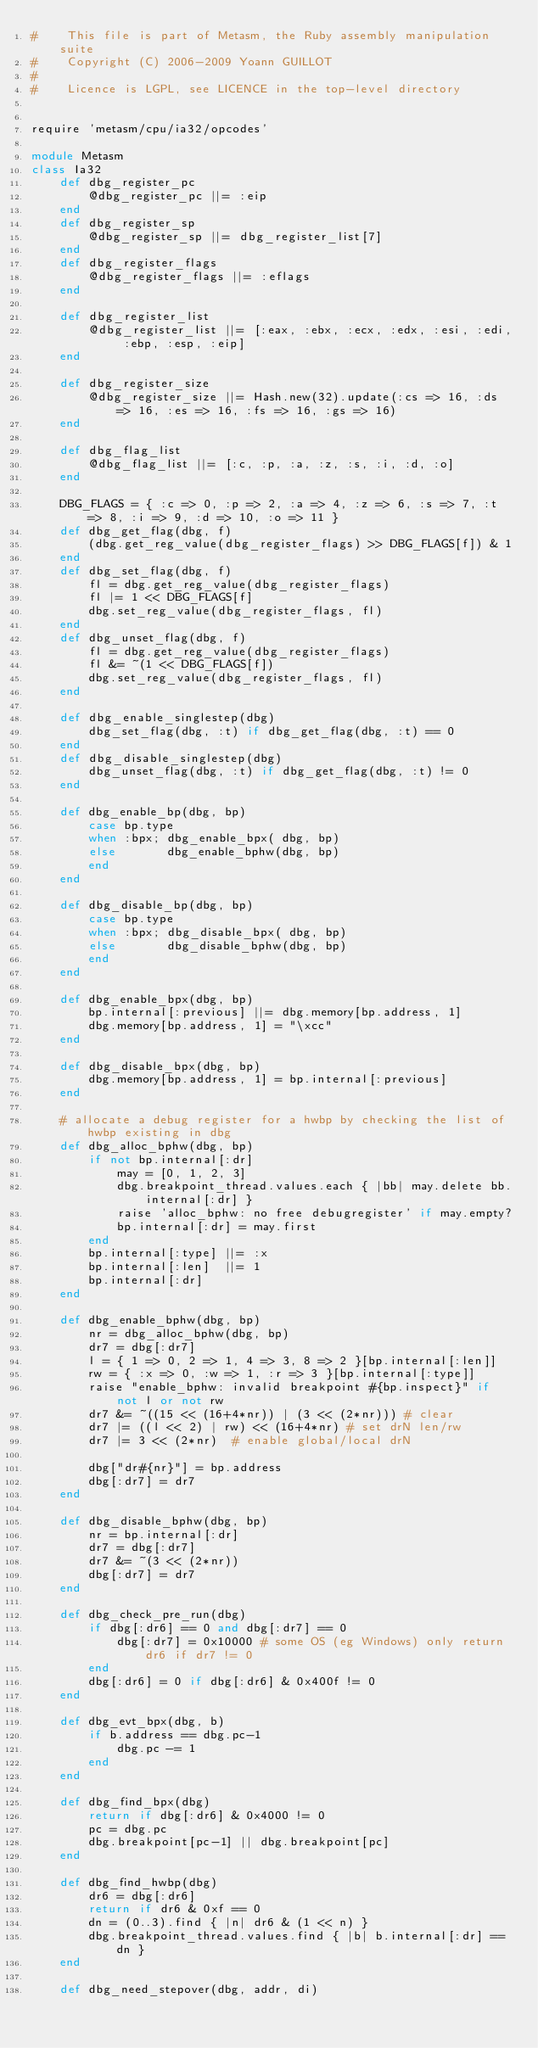<code> <loc_0><loc_0><loc_500><loc_500><_Ruby_>#    This file is part of Metasm, the Ruby assembly manipulation suite
#    Copyright (C) 2006-2009 Yoann GUILLOT
#
#    Licence is LGPL, see LICENCE in the top-level directory


require 'metasm/cpu/ia32/opcodes'

module Metasm
class Ia32
	def dbg_register_pc
		@dbg_register_pc ||= :eip
	end
	def dbg_register_sp
		@dbg_register_sp ||= dbg_register_list[7]
	end
	def dbg_register_flags
		@dbg_register_flags ||= :eflags
	end

	def dbg_register_list
		@dbg_register_list ||= [:eax, :ebx, :ecx, :edx, :esi, :edi, :ebp, :esp, :eip]
	end

	def dbg_register_size
		@dbg_register_size ||= Hash.new(32).update(:cs => 16, :ds => 16, :es => 16, :fs => 16, :gs => 16)
	end

	def dbg_flag_list
		@dbg_flag_list ||= [:c, :p, :a, :z, :s, :i, :d, :o]
	end

	DBG_FLAGS = { :c => 0, :p => 2, :a => 4, :z => 6, :s => 7, :t => 8, :i => 9, :d => 10, :o => 11 }
	def dbg_get_flag(dbg, f)
		(dbg.get_reg_value(dbg_register_flags) >> DBG_FLAGS[f]) & 1
	end
	def dbg_set_flag(dbg, f)
		fl = dbg.get_reg_value(dbg_register_flags)
		fl |= 1 << DBG_FLAGS[f]
		dbg.set_reg_value(dbg_register_flags, fl)
	end
	def dbg_unset_flag(dbg, f)
		fl = dbg.get_reg_value(dbg_register_flags)
		fl &= ~(1 << DBG_FLAGS[f])
		dbg.set_reg_value(dbg_register_flags, fl)
	end

	def dbg_enable_singlestep(dbg)
		dbg_set_flag(dbg, :t) if dbg_get_flag(dbg, :t) == 0
	end
	def dbg_disable_singlestep(dbg)
		dbg_unset_flag(dbg, :t) if dbg_get_flag(dbg, :t) != 0
	end

	def dbg_enable_bp(dbg, bp)
		case bp.type
		when :bpx; dbg_enable_bpx( dbg, bp)
		else       dbg_enable_bphw(dbg, bp)
		end
	end

	def dbg_disable_bp(dbg, bp)
		case bp.type
		when :bpx; dbg_disable_bpx( dbg, bp)
		else       dbg_disable_bphw(dbg, bp)
		end
	end

	def dbg_enable_bpx(dbg, bp)
		bp.internal[:previous] ||= dbg.memory[bp.address, 1]
		dbg.memory[bp.address, 1] = "\xcc"
	end

	def dbg_disable_bpx(dbg, bp)
		dbg.memory[bp.address, 1] = bp.internal[:previous]
	end

	# allocate a debug register for a hwbp by checking the list of hwbp existing in dbg
	def dbg_alloc_bphw(dbg, bp)
		if not bp.internal[:dr]
			may = [0, 1, 2, 3]
			dbg.breakpoint_thread.values.each { |bb| may.delete bb.internal[:dr] }
			raise 'alloc_bphw: no free debugregister' if may.empty?
			bp.internal[:dr] = may.first
		end
		bp.internal[:type] ||= :x
		bp.internal[:len]  ||= 1
		bp.internal[:dr]
	end

	def dbg_enable_bphw(dbg, bp)
		nr = dbg_alloc_bphw(dbg, bp)
		dr7 = dbg[:dr7]
		l = { 1 => 0, 2 => 1, 4 => 3, 8 => 2 }[bp.internal[:len]]
		rw = { :x => 0, :w => 1, :r => 3 }[bp.internal[:type]]
		raise "enable_bphw: invalid breakpoint #{bp.inspect}" if not l or not rw
		dr7 &= ~((15 << (16+4*nr)) | (3 << (2*nr)))	# clear
		dr7 |= ((l << 2) | rw) << (16+4*nr)	# set drN len/rw
		dr7 |= 3 << (2*nr)	# enable global/local drN

		dbg["dr#{nr}"] = bp.address
		dbg[:dr7] = dr7
	end

	def dbg_disable_bphw(dbg, bp)
		nr = bp.internal[:dr]
		dr7 = dbg[:dr7]
		dr7 &= ~(3 << (2*nr))
		dbg[:dr7] = dr7
	end

	def dbg_check_pre_run(dbg)
		if dbg[:dr6] == 0 and dbg[:dr7] == 0
			dbg[:dr7] = 0x10000	# some OS (eg Windows) only return dr6 if dr7 != 0
		end
		dbg[:dr6] = 0 if dbg[:dr6] & 0x400f != 0
	end

	def dbg_evt_bpx(dbg, b)
		if b.address == dbg.pc-1
			dbg.pc -= 1
		end
	end

	def dbg_find_bpx(dbg)
		return if dbg[:dr6] & 0x4000 != 0
		pc = dbg.pc
		dbg.breakpoint[pc-1] || dbg.breakpoint[pc]
	end

	def dbg_find_hwbp(dbg)
		dr6 = dbg[:dr6]
		return if dr6 & 0xf == 0
		dn = (0..3).find { |n| dr6 & (1 << n) }
		dbg.breakpoint_thread.values.find { |b| b.internal[:dr] == dn }
	end

	def dbg_need_stepover(dbg, addr, di)</code> 